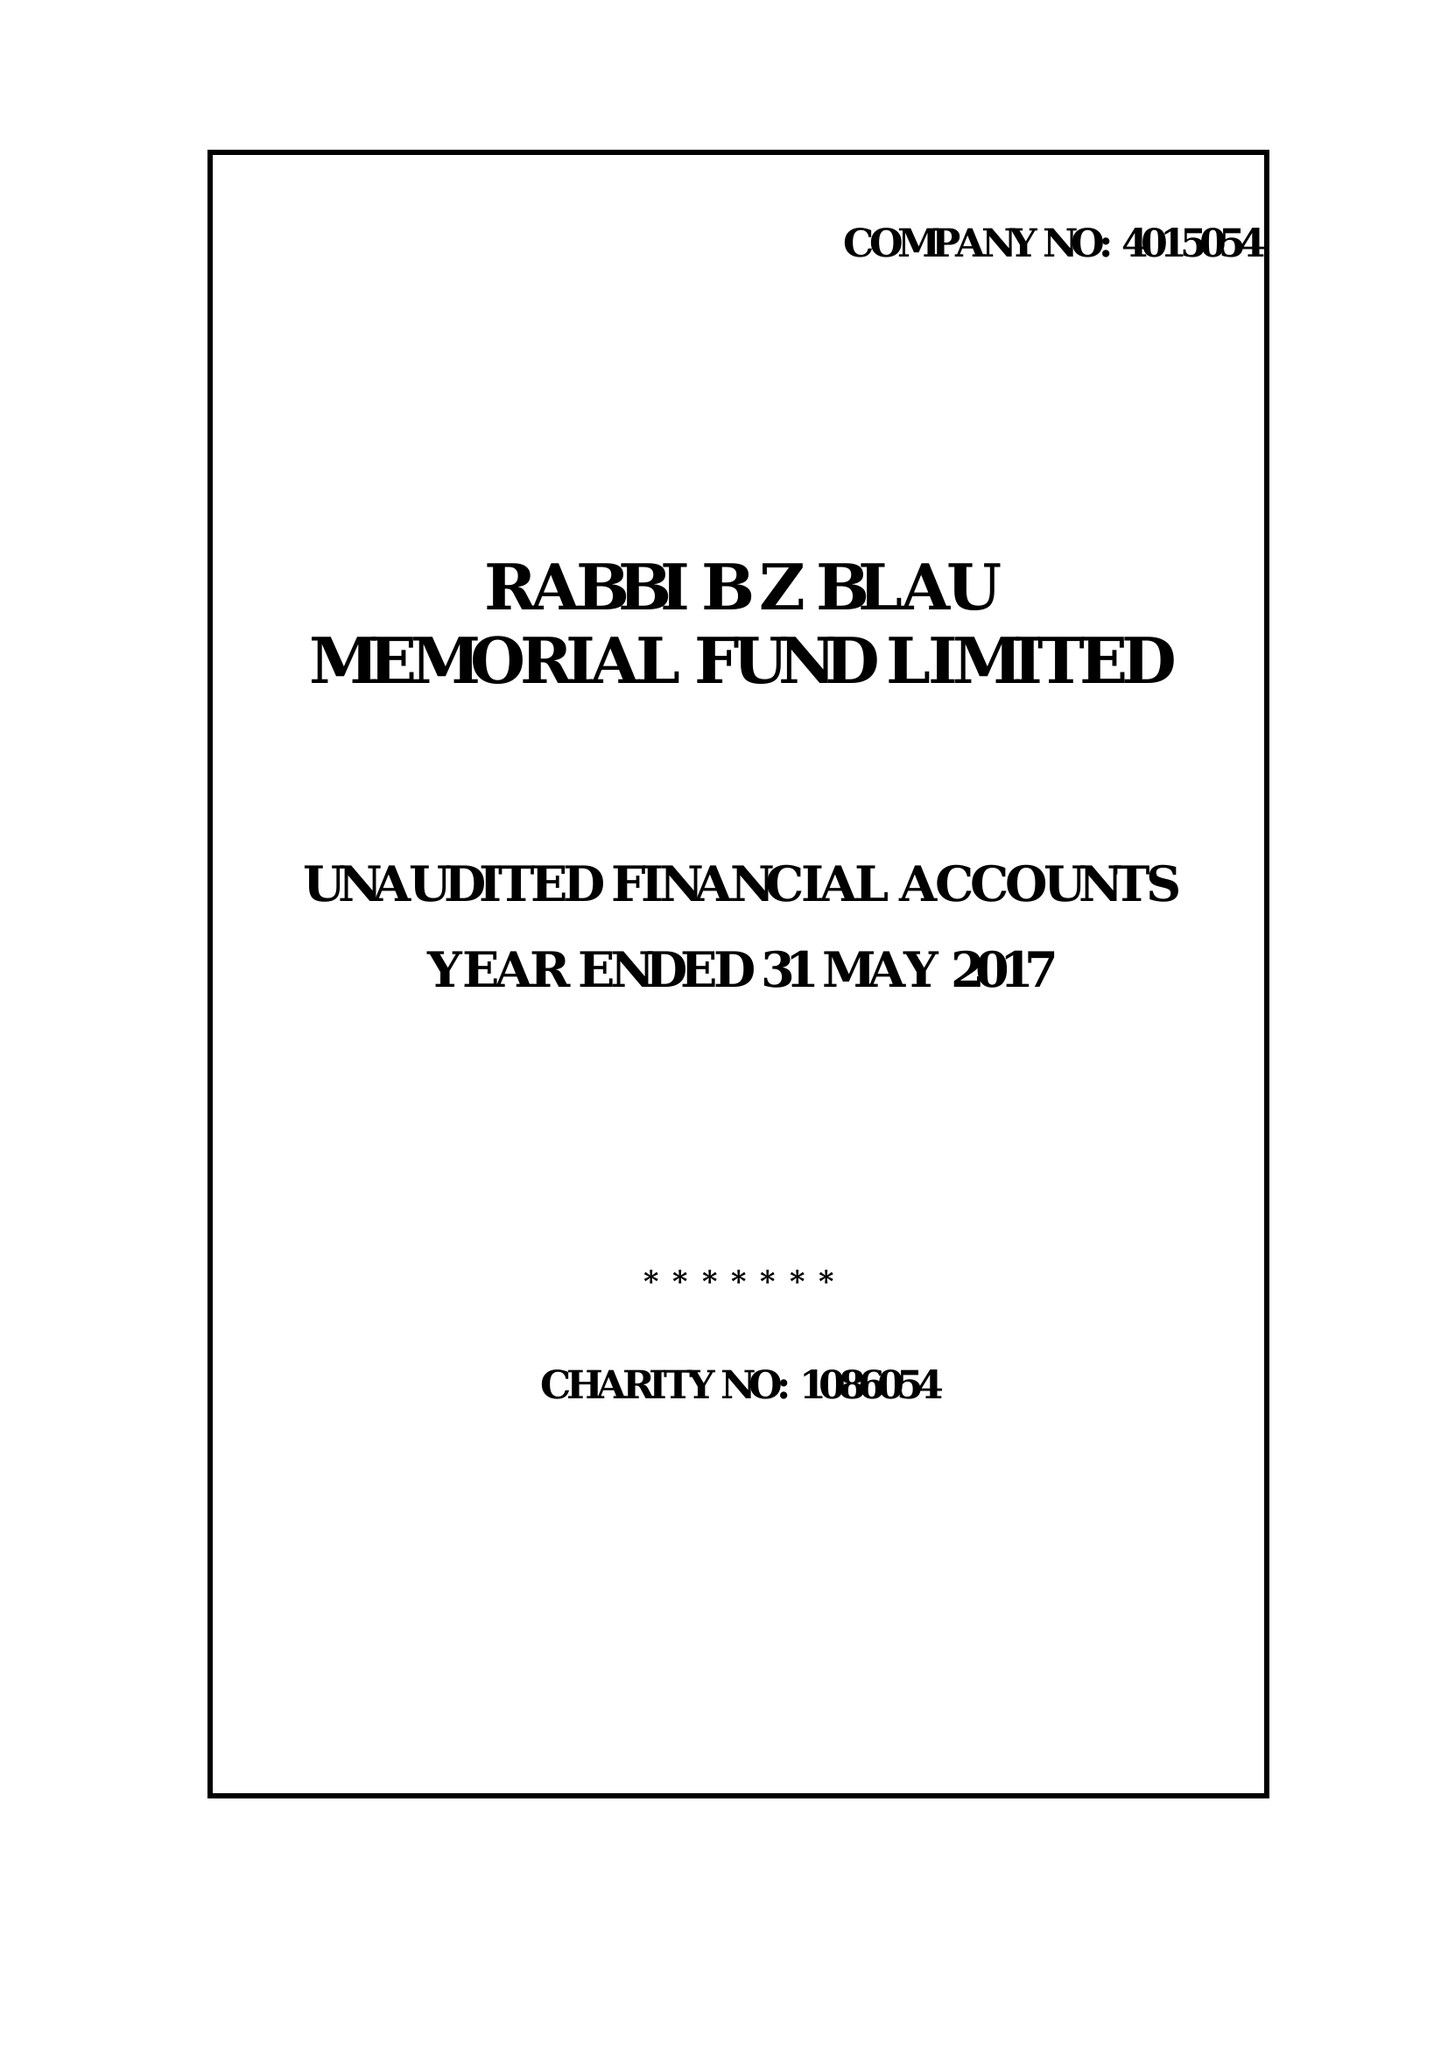What is the value for the report_date?
Answer the question using a single word or phrase. 2017-05-31 